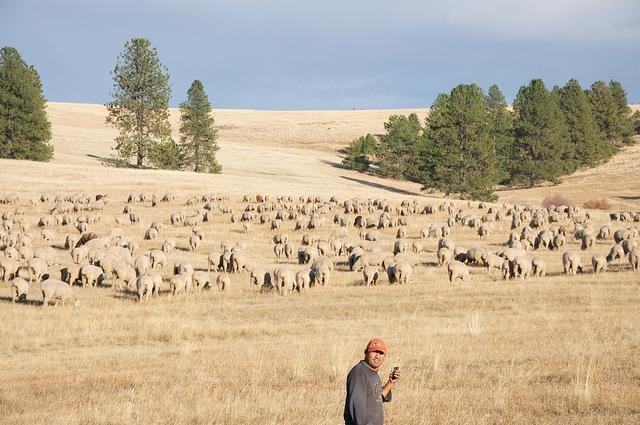Why is he standing far from the animals?
Answer the question by selecting the correct answer among the 4 following choices.
Options: Avoid spooking, dangerous animals, he's afraid, private property. Avoid spooking. 